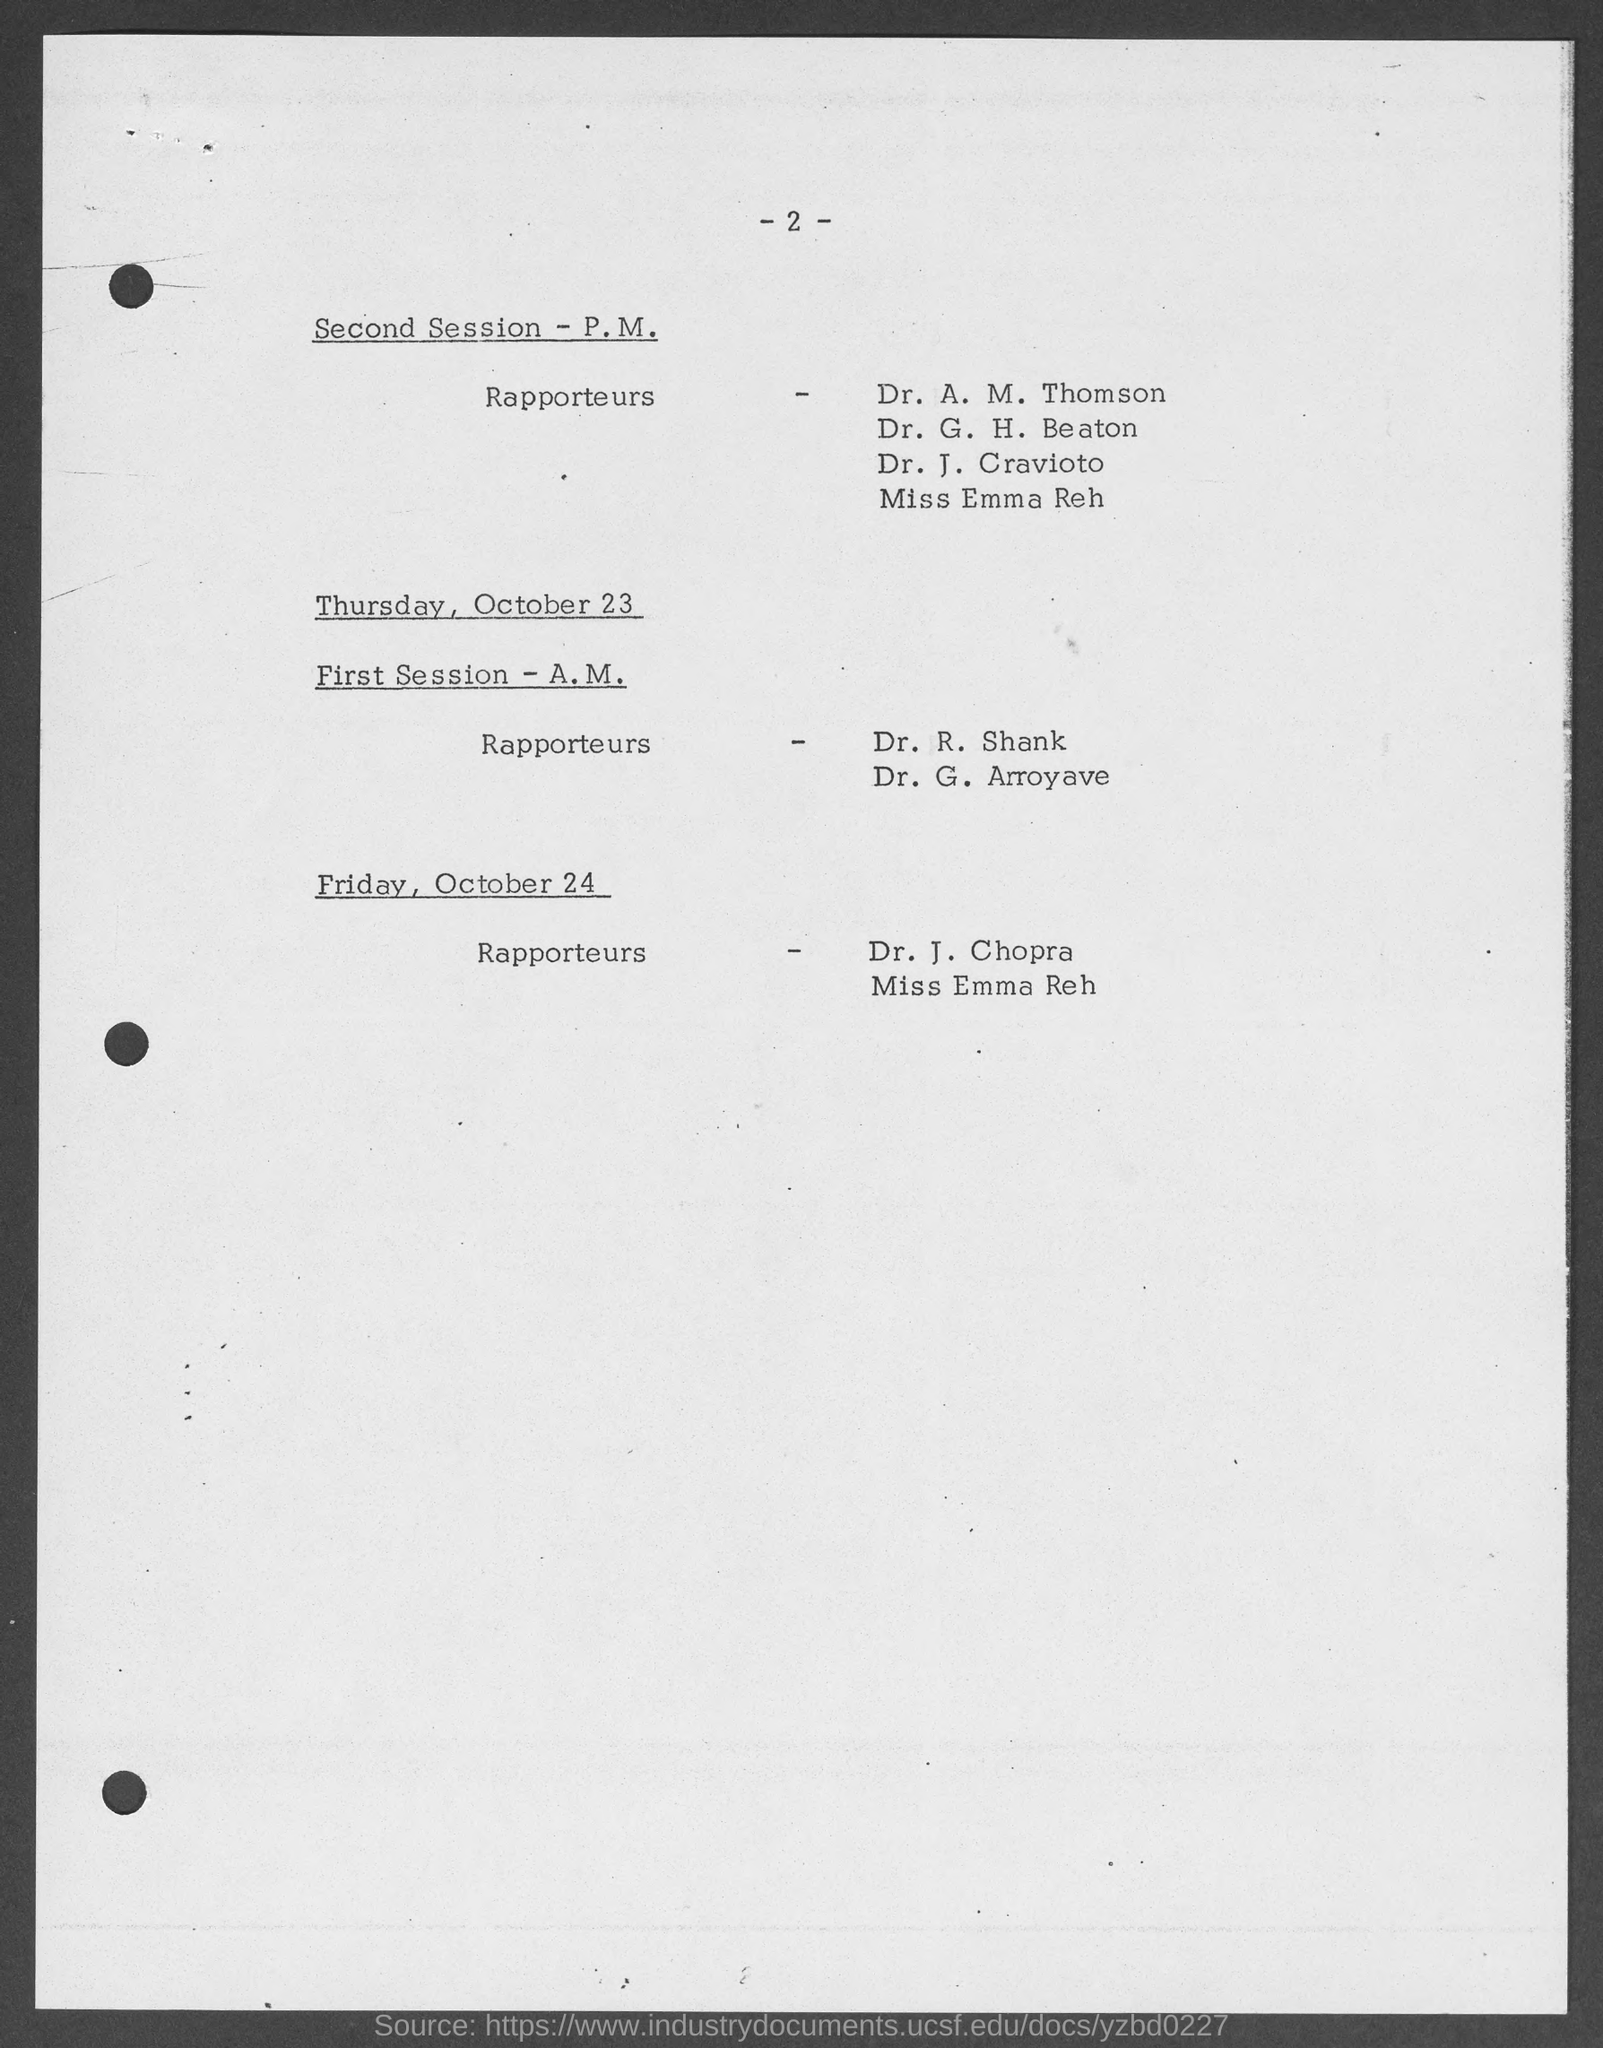What is the page number?
Keep it short and to the point. - 2 -. On which day is Dr. J. Chopra the Rapporteur?
Give a very brief answer. Friday. 